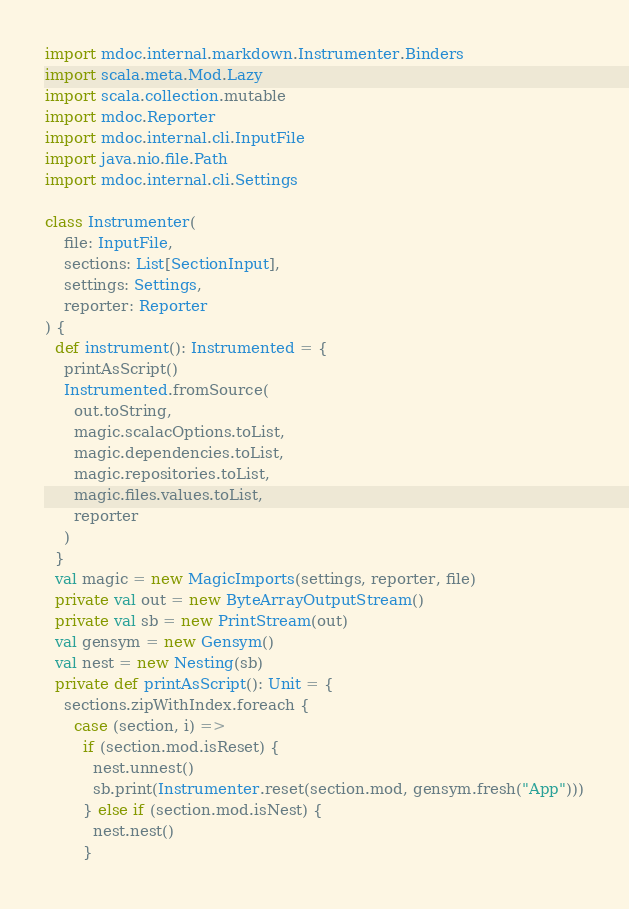Convert code to text. <code><loc_0><loc_0><loc_500><loc_500><_Scala_>import mdoc.internal.markdown.Instrumenter.Binders
import scala.meta.Mod.Lazy
import scala.collection.mutable
import mdoc.Reporter
import mdoc.internal.cli.InputFile
import java.nio.file.Path
import mdoc.internal.cli.Settings

class Instrumenter(
    file: InputFile,
    sections: List[SectionInput],
    settings: Settings,
    reporter: Reporter
) {
  def instrument(): Instrumented = {
    printAsScript()
    Instrumented.fromSource(
      out.toString,
      magic.scalacOptions.toList,
      magic.dependencies.toList,
      magic.repositories.toList,
      magic.files.values.toList,
      reporter
    )
  }
  val magic = new MagicImports(settings, reporter, file)
  private val out = new ByteArrayOutputStream()
  private val sb = new PrintStream(out)
  val gensym = new Gensym()
  val nest = new Nesting(sb)
  private def printAsScript(): Unit = {
    sections.zipWithIndex.foreach {
      case (section, i) =>
        if (section.mod.isReset) {
          nest.unnest()
          sb.print(Instrumenter.reset(section.mod, gensym.fresh("App")))
        } else if (section.mod.isNest) {
          nest.nest()
        }</code> 